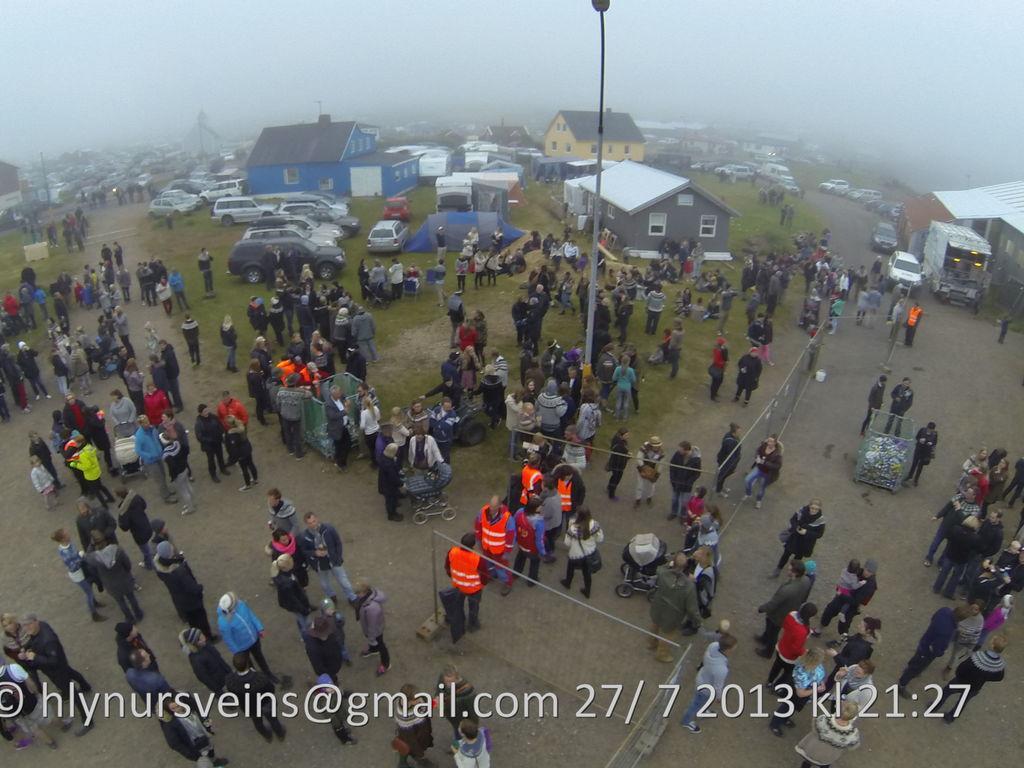How would you summarize this image in a sentence or two? In this image we can see these people are standing on the ground, we can see barrier gates, light poles, vehicles parked here, we can see houses and fog in the background. Here we can see the watermark at the bottom of the image. 